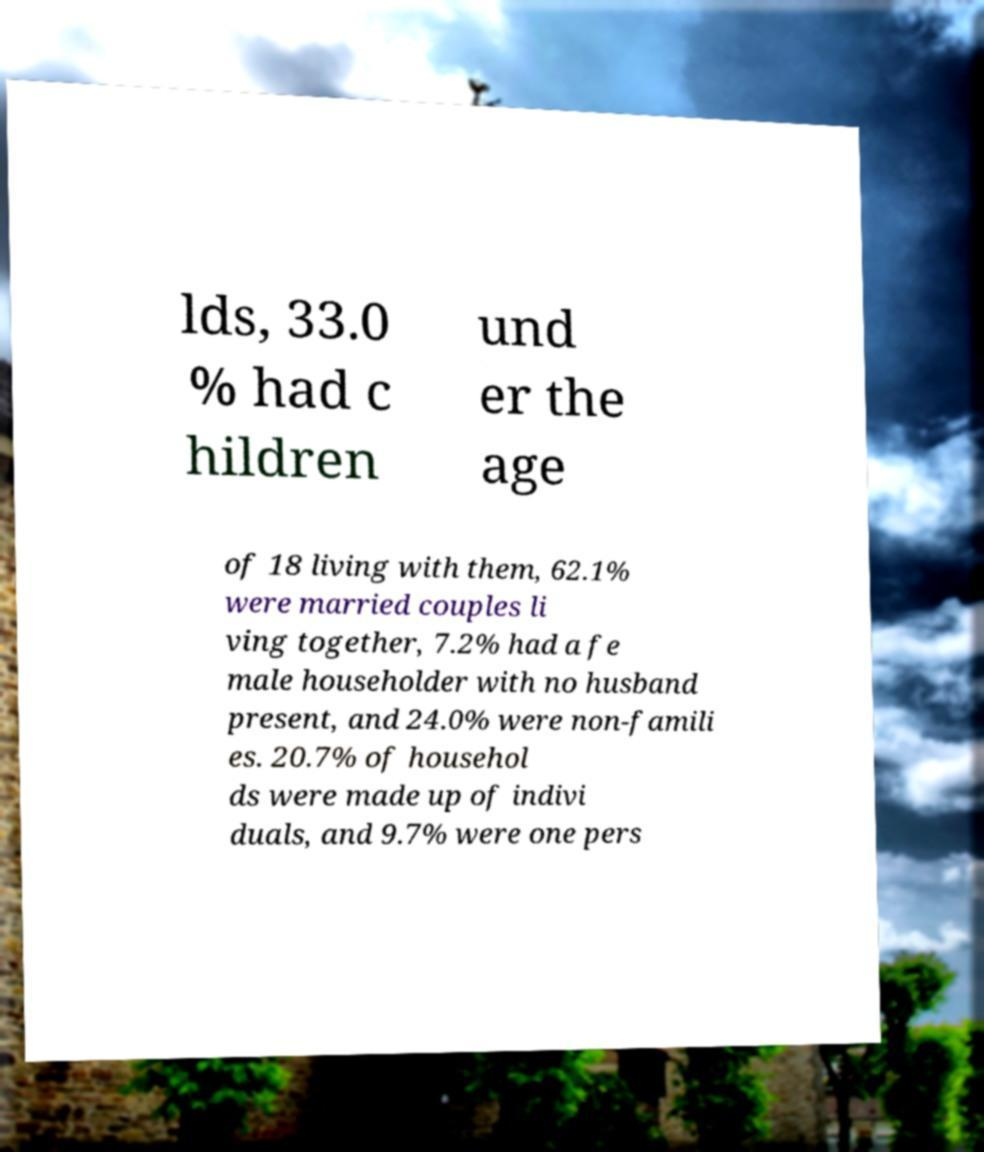Could you extract and type out the text from this image? lds, 33.0 % had c hildren und er the age of 18 living with them, 62.1% were married couples li ving together, 7.2% had a fe male householder with no husband present, and 24.0% were non-famili es. 20.7% of househol ds were made up of indivi duals, and 9.7% were one pers 